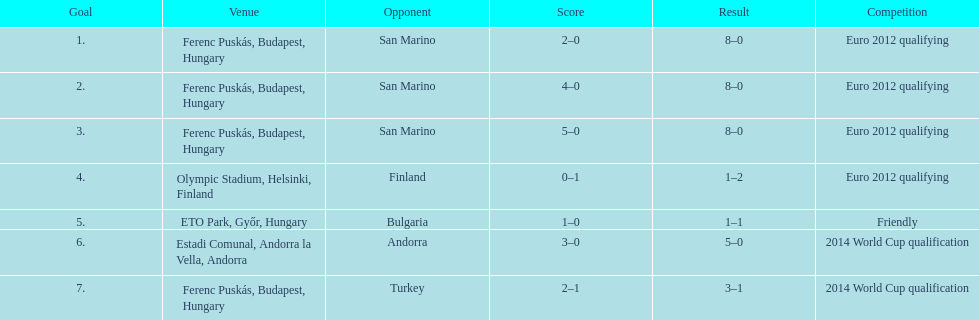Help me parse the entirety of this table. {'header': ['Goal', 'Venue', 'Opponent', 'Score', 'Result', 'Competition'], 'rows': [['1.', 'Ferenc Puskás, Budapest, Hungary', 'San Marino', '2–0', '8–0', 'Euro 2012 qualifying'], ['2.', 'Ferenc Puskás, Budapest, Hungary', 'San Marino', '4–0', '8–0', 'Euro 2012 qualifying'], ['3.', 'Ferenc Puskás, Budapest, Hungary', 'San Marino', '5–0', '8–0', 'Euro 2012 qualifying'], ['4.', 'Olympic Stadium, Helsinki, Finland', 'Finland', '0–1', '1–2', 'Euro 2012 qualifying'], ['5.', 'ETO Park, Győr, Hungary', 'Bulgaria', '1–0', '1–1', 'Friendly'], ['6.', 'Estadi Comunal, Andorra la Vella, Andorra', 'Andorra', '3–0', '5–0', '2014 World Cup qualification'], ['7.', 'Ferenc Puskás, Budapest, Hungary', 'Turkey', '2–1', '3–1', '2014 World Cup qualification']]} When was ádám szalai's debut international goal made? 8 October 2010. 